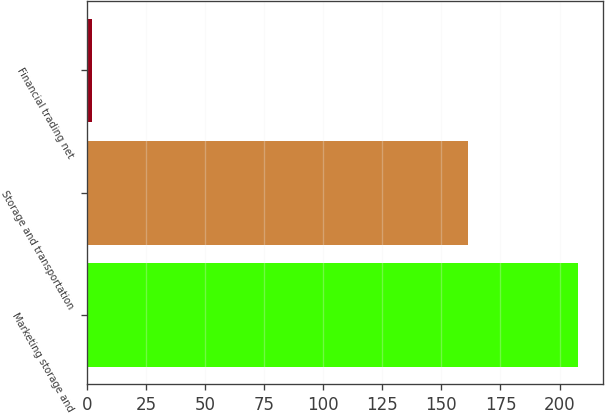Convert chart to OTSL. <chart><loc_0><loc_0><loc_500><loc_500><bar_chart><fcel>Marketing storage and<fcel>Storage and transportation<fcel>Financial trading net<nl><fcel>208<fcel>161.2<fcel>1.9<nl></chart> 